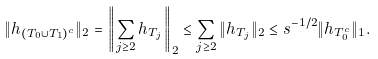Convert formula to latex. <formula><loc_0><loc_0><loc_500><loc_500>\| h _ { ( T _ { 0 } \cup T _ { 1 } ) ^ { c } } \| _ { 2 } = \left \| \sum _ { j \geq 2 } h _ { T _ { j } } \right \| _ { 2 } \leq \sum _ { j \geq 2 } \| h _ { T _ { j } } \| _ { 2 } \leq s ^ { - 1 / 2 } \| h _ { T _ { 0 } ^ { c } } \| _ { 1 } .</formula> 